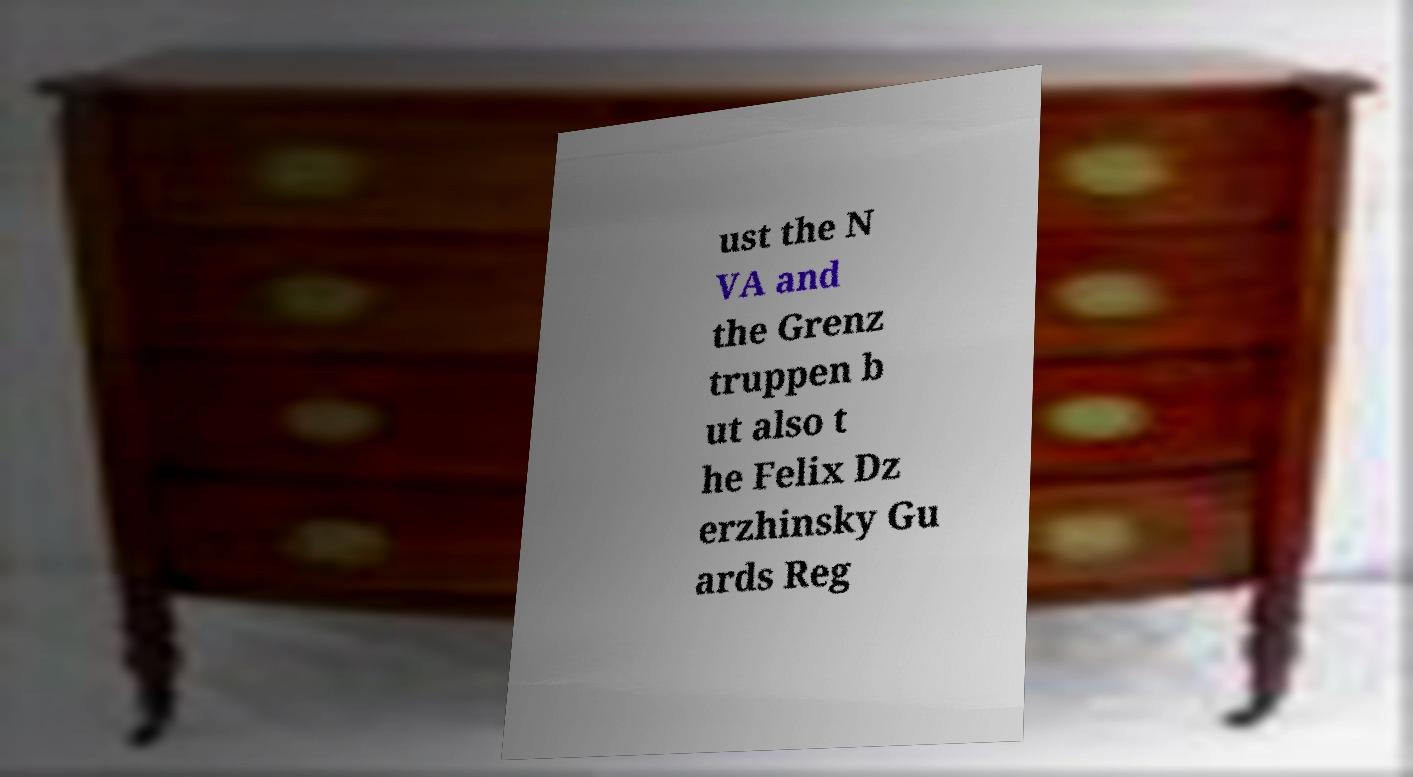For documentation purposes, I need the text within this image transcribed. Could you provide that? ust the N VA and the Grenz truppen b ut also t he Felix Dz erzhinsky Gu ards Reg 